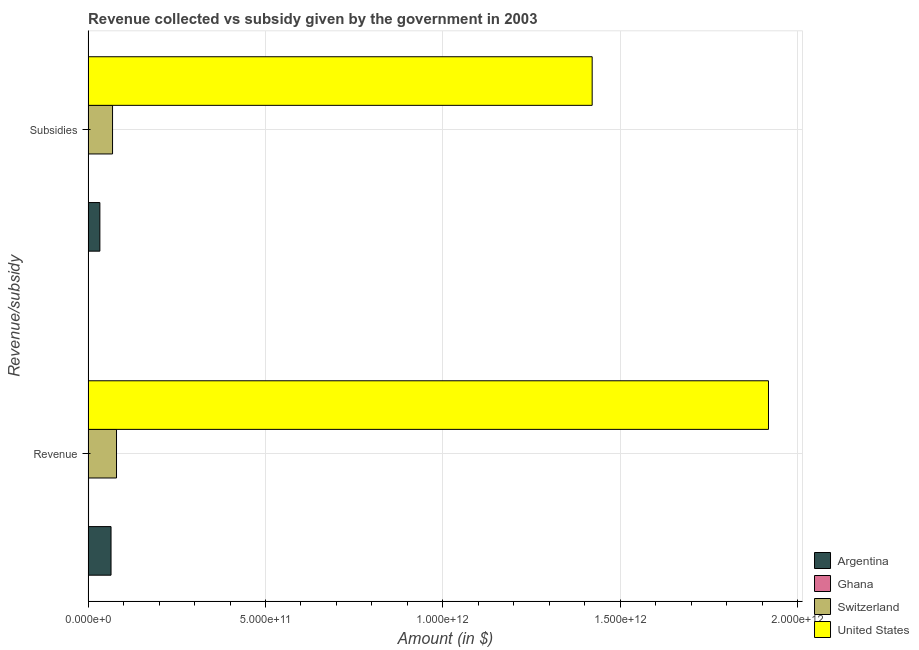How many groups of bars are there?
Provide a short and direct response. 2. Are the number of bars per tick equal to the number of legend labels?
Ensure brevity in your answer.  Yes. How many bars are there on the 2nd tick from the top?
Keep it short and to the point. 4. What is the label of the 1st group of bars from the top?
Give a very brief answer. Subsidies. What is the amount of subsidies given in Ghana?
Offer a terse response. 2.80e+08. Across all countries, what is the maximum amount of revenue collected?
Give a very brief answer. 1.92e+12. Across all countries, what is the minimum amount of revenue collected?
Your answer should be compact. 1.31e+09. In which country was the amount of subsidies given minimum?
Your answer should be very brief. Ghana. What is the total amount of revenue collected in the graph?
Your answer should be compact. 2.06e+12. What is the difference between the amount of revenue collected in Switzerland and that in Argentina?
Offer a very short reply. 1.55e+1. What is the difference between the amount of revenue collected in Ghana and the amount of subsidies given in United States?
Make the answer very short. -1.42e+12. What is the average amount of revenue collected per country?
Provide a short and direct response. 5.16e+11. What is the difference between the amount of revenue collected and amount of subsidies given in Switzerland?
Ensure brevity in your answer.  1.12e+1. In how many countries, is the amount of subsidies given greater than 1300000000000 $?
Provide a short and direct response. 1. What is the ratio of the amount of subsidies given in Switzerland to that in Ghana?
Your response must be concise. 246.06. Is the amount of revenue collected in Ghana less than that in Argentina?
Offer a terse response. Yes. In how many countries, is the amount of revenue collected greater than the average amount of revenue collected taken over all countries?
Provide a succinct answer. 1. What does the 3rd bar from the bottom in Subsidies represents?
Keep it short and to the point. Switzerland. How many bars are there?
Provide a short and direct response. 8. How many countries are there in the graph?
Give a very brief answer. 4. What is the difference between two consecutive major ticks on the X-axis?
Your response must be concise. 5.00e+11. Does the graph contain any zero values?
Keep it short and to the point. No. Where does the legend appear in the graph?
Provide a succinct answer. Bottom right. How many legend labels are there?
Your answer should be compact. 4. How are the legend labels stacked?
Ensure brevity in your answer.  Vertical. What is the title of the graph?
Provide a succinct answer. Revenue collected vs subsidy given by the government in 2003. What is the label or title of the X-axis?
Make the answer very short. Amount (in $). What is the label or title of the Y-axis?
Offer a very short reply. Revenue/subsidy. What is the Amount (in $) in Argentina in Revenue?
Provide a short and direct response. 6.47e+1. What is the Amount (in $) of Ghana in Revenue?
Provide a succinct answer. 1.31e+09. What is the Amount (in $) of Switzerland in Revenue?
Keep it short and to the point. 8.01e+1. What is the Amount (in $) in United States in Revenue?
Provide a short and direct response. 1.92e+12. What is the Amount (in $) in Argentina in Subsidies?
Give a very brief answer. 3.32e+1. What is the Amount (in $) of Ghana in Subsidies?
Offer a very short reply. 2.80e+08. What is the Amount (in $) in Switzerland in Subsidies?
Provide a short and direct response. 6.89e+1. What is the Amount (in $) in United States in Subsidies?
Offer a very short reply. 1.42e+12. Across all Revenue/subsidy, what is the maximum Amount (in $) in Argentina?
Your answer should be compact. 6.47e+1. Across all Revenue/subsidy, what is the maximum Amount (in $) of Ghana?
Make the answer very short. 1.31e+09. Across all Revenue/subsidy, what is the maximum Amount (in $) of Switzerland?
Your response must be concise. 8.01e+1. Across all Revenue/subsidy, what is the maximum Amount (in $) in United States?
Provide a succinct answer. 1.92e+12. Across all Revenue/subsidy, what is the minimum Amount (in $) in Argentina?
Your answer should be very brief. 3.32e+1. Across all Revenue/subsidy, what is the minimum Amount (in $) in Ghana?
Your answer should be compact. 2.80e+08. Across all Revenue/subsidy, what is the minimum Amount (in $) of Switzerland?
Offer a very short reply. 6.89e+1. Across all Revenue/subsidy, what is the minimum Amount (in $) of United States?
Keep it short and to the point. 1.42e+12. What is the total Amount (in $) in Argentina in the graph?
Keep it short and to the point. 9.79e+1. What is the total Amount (in $) of Ghana in the graph?
Ensure brevity in your answer.  1.59e+09. What is the total Amount (in $) in Switzerland in the graph?
Offer a terse response. 1.49e+11. What is the total Amount (in $) in United States in the graph?
Your response must be concise. 3.34e+12. What is the difference between the Amount (in $) in Argentina in Revenue and that in Subsidies?
Ensure brevity in your answer.  3.14e+1. What is the difference between the Amount (in $) in Ghana in Revenue and that in Subsidies?
Your answer should be compact. 1.03e+09. What is the difference between the Amount (in $) of Switzerland in Revenue and that in Subsidies?
Give a very brief answer. 1.12e+1. What is the difference between the Amount (in $) of United States in Revenue and that in Subsidies?
Ensure brevity in your answer.  4.97e+11. What is the difference between the Amount (in $) of Argentina in Revenue and the Amount (in $) of Ghana in Subsidies?
Offer a terse response. 6.44e+1. What is the difference between the Amount (in $) in Argentina in Revenue and the Amount (in $) in Switzerland in Subsidies?
Offer a very short reply. -4.26e+09. What is the difference between the Amount (in $) in Argentina in Revenue and the Amount (in $) in United States in Subsidies?
Give a very brief answer. -1.36e+12. What is the difference between the Amount (in $) of Ghana in Revenue and the Amount (in $) of Switzerland in Subsidies?
Your answer should be compact. -6.76e+1. What is the difference between the Amount (in $) of Ghana in Revenue and the Amount (in $) of United States in Subsidies?
Provide a succinct answer. -1.42e+12. What is the difference between the Amount (in $) of Switzerland in Revenue and the Amount (in $) of United States in Subsidies?
Give a very brief answer. -1.34e+12. What is the average Amount (in $) in Argentina per Revenue/subsidy?
Your answer should be compact. 4.89e+1. What is the average Amount (in $) in Ghana per Revenue/subsidy?
Your answer should be very brief. 7.94e+08. What is the average Amount (in $) in Switzerland per Revenue/subsidy?
Keep it short and to the point. 7.45e+1. What is the average Amount (in $) in United States per Revenue/subsidy?
Offer a terse response. 1.67e+12. What is the difference between the Amount (in $) in Argentina and Amount (in $) in Ghana in Revenue?
Provide a short and direct response. 6.33e+1. What is the difference between the Amount (in $) of Argentina and Amount (in $) of Switzerland in Revenue?
Provide a short and direct response. -1.55e+1. What is the difference between the Amount (in $) of Argentina and Amount (in $) of United States in Revenue?
Keep it short and to the point. -1.85e+12. What is the difference between the Amount (in $) of Ghana and Amount (in $) of Switzerland in Revenue?
Provide a short and direct response. -7.88e+1. What is the difference between the Amount (in $) of Ghana and Amount (in $) of United States in Revenue?
Your answer should be compact. -1.92e+12. What is the difference between the Amount (in $) of Switzerland and Amount (in $) of United States in Revenue?
Your answer should be very brief. -1.84e+12. What is the difference between the Amount (in $) in Argentina and Amount (in $) in Ghana in Subsidies?
Provide a short and direct response. 3.29e+1. What is the difference between the Amount (in $) of Argentina and Amount (in $) of Switzerland in Subsidies?
Give a very brief answer. -3.57e+1. What is the difference between the Amount (in $) in Argentina and Amount (in $) in United States in Subsidies?
Offer a terse response. -1.39e+12. What is the difference between the Amount (in $) of Ghana and Amount (in $) of Switzerland in Subsidies?
Offer a very short reply. -6.86e+1. What is the difference between the Amount (in $) of Ghana and Amount (in $) of United States in Subsidies?
Ensure brevity in your answer.  -1.42e+12. What is the difference between the Amount (in $) in Switzerland and Amount (in $) in United States in Subsidies?
Your response must be concise. -1.35e+12. What is the ratio of the Amount (in $) of Argentina in Revenue to that in Subsidies?
Give a very brief answer. 1.95. What is the ratio of the Amount (in $) of Ghana in Revenue to that in Subsidies?
Your response must be concise. 4.67. What is the ratio of the Amount (in $) of Switzerland in Revenue to that in Subsidies?
Make the answer very short. 1.16. What is the ratio of the Amount (in $) of United States in Revenue to that in Subsidies?
Provide a succinct answer. 1.35. What is the difference between the highest and the second highest Amount (in $) of Argentina?
Your answer should be compact. 3.14e+1. What is the difference between the highest and the second highest Amount (in $) in Ghana?
Give a very brief answer. 1.03e+09. What is the difference between the highest and the second highest Amount (in $) in Switzerland?
Give a very brief answer. 1.12e+1. What is the difference between the highest and the second highest Amount (in $) in United States?
Keep it short and to the point. 4.97e+11. What is the difference between the highest and the lowest Amount (in $) in Argentina?
Provide a short and direct response. 3.14e+1. What is the difference between the highest and the lowest Amount (in $) in Ghana?
Give a very brief answer. 1.03e+09. What is the difference between the highest and the lowest Amount (in $) of Switzerland?
Provide a succinct answer. 1.12e+1. What is the difference between the highest and the lowest Amount (in $) of United States?
Provide a succinct answer. 4.97e+11. 